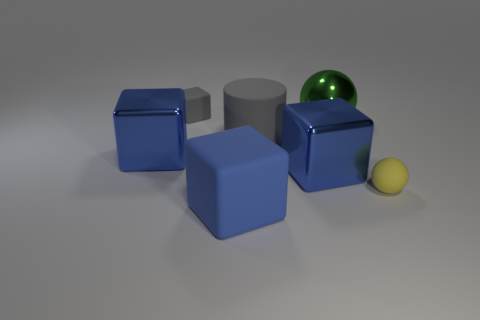How many blue blocks must be subtracted to get 1 blue blocks? 2 Subtract all red spheres. How many blue cubes are left? 3 Add 2 large yellow metal cylinders. How many objects exist? 9 Subtract all spheres. How many objects are left? 5 Subtract 0 purple blocks. How many objects are left? 7 Subtract all big blue things. Subtract all matte things. How many objects are left? 0 Add 2 large gray things. How many large gray things are left? 3 Add 4 brown metal cylinders. How many brown metal cylinders exist? 4 